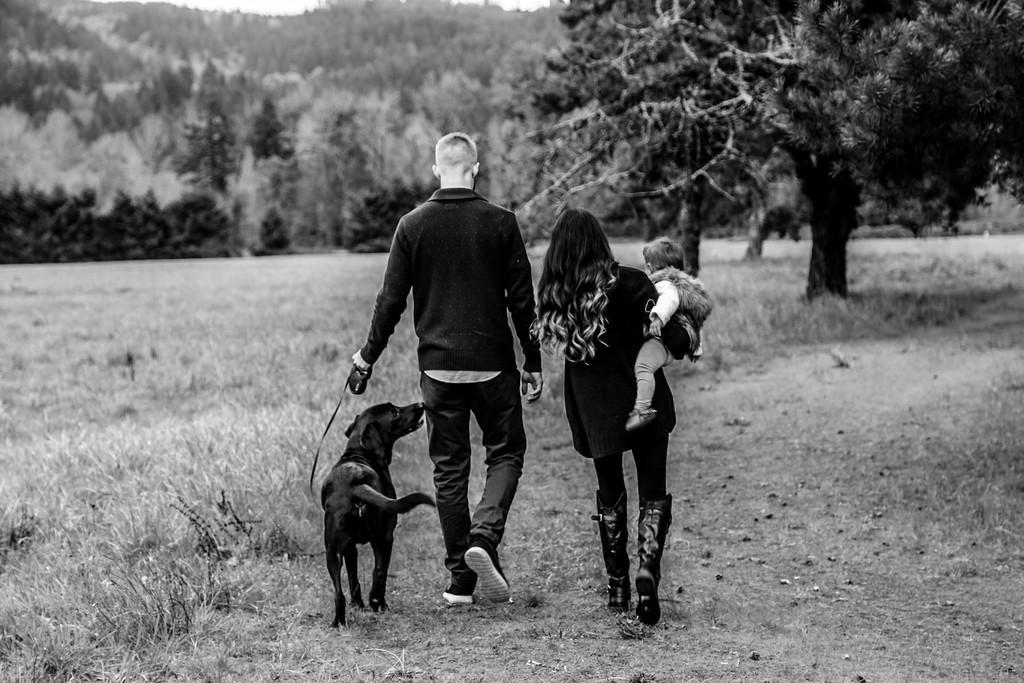Could you give a brief overview of what you see in this image? Here we can see two persons were walking. And man holding dog and woman holding her baby. Coming to the background we can see trees and grass. 